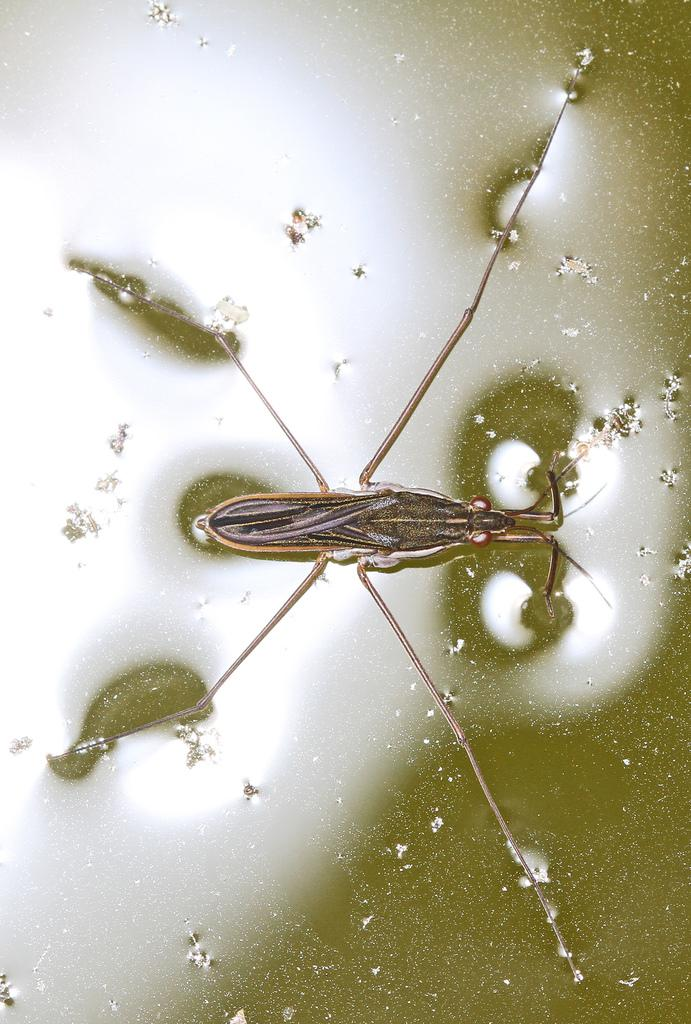What type of creature is present in the image? There is an insect in the image. Where is the insect located in the image? The insect is on a water surface. How many pizzas are floating in the water next to the insect? There are no pizzas present in the image; it only features an insect on a water surface. 